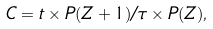<formula> <loc_0><loc_0><loc_500><loc_500>C = t \times P ( Z + 1 ) / \tau \times P ( Z ) ,</formula> 